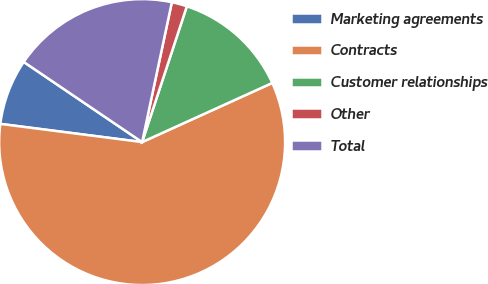Convert chart. <chart><loc_0><loc_0><loc_500><loc_500><pie_chart><fcel>Marketing agreements<fcel>Contracts<fcel>Customer relationships<fcel>Other<fcel>Total<nl><fcel>7.44%<fcel>58.82%<fcel>13.15%<fcel>1.73%<fcel>18.86%<nl></chart> 